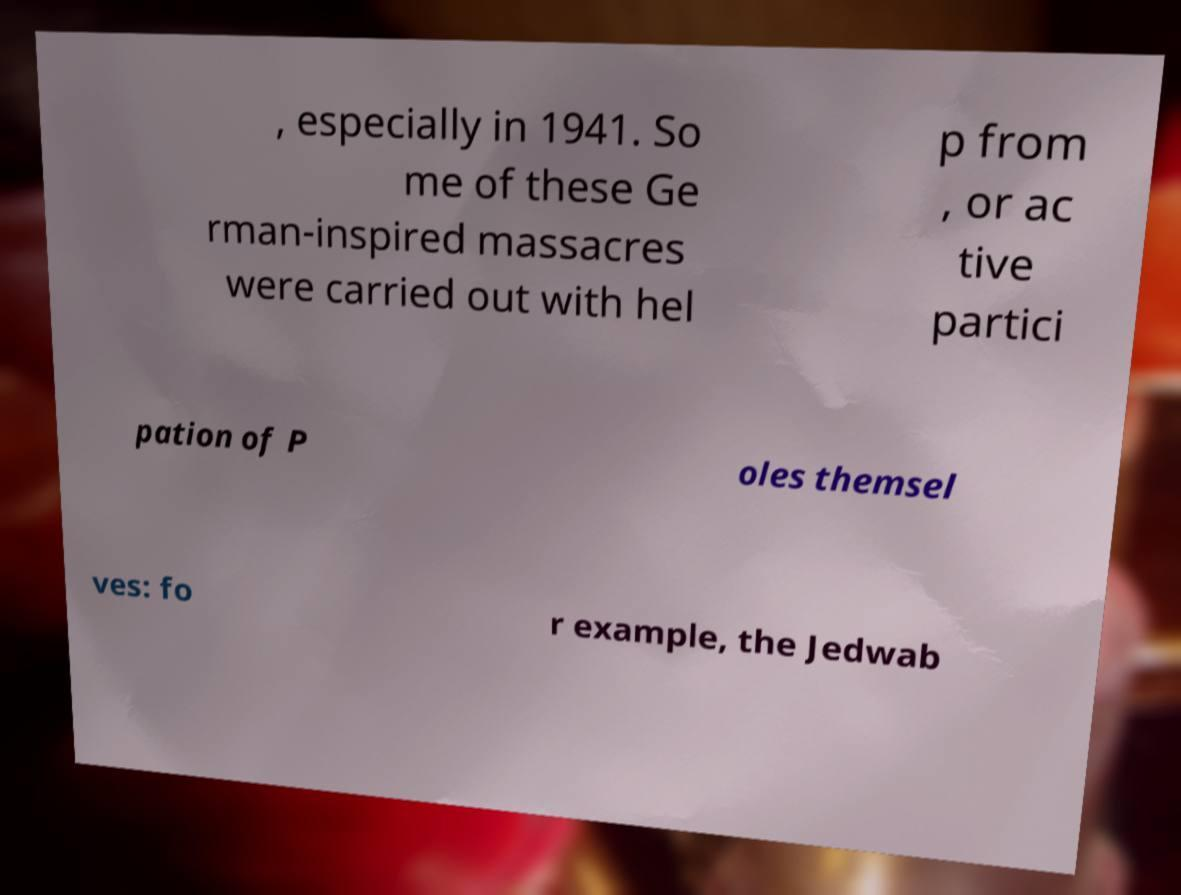Please identify and transcribe the text found in this image. , especially in 1941. So me of these Ge rman-inspired massacres were carried out with hel p from , or ac tive partici pation of P oles themsel ves: fo r example, the Jedwab 